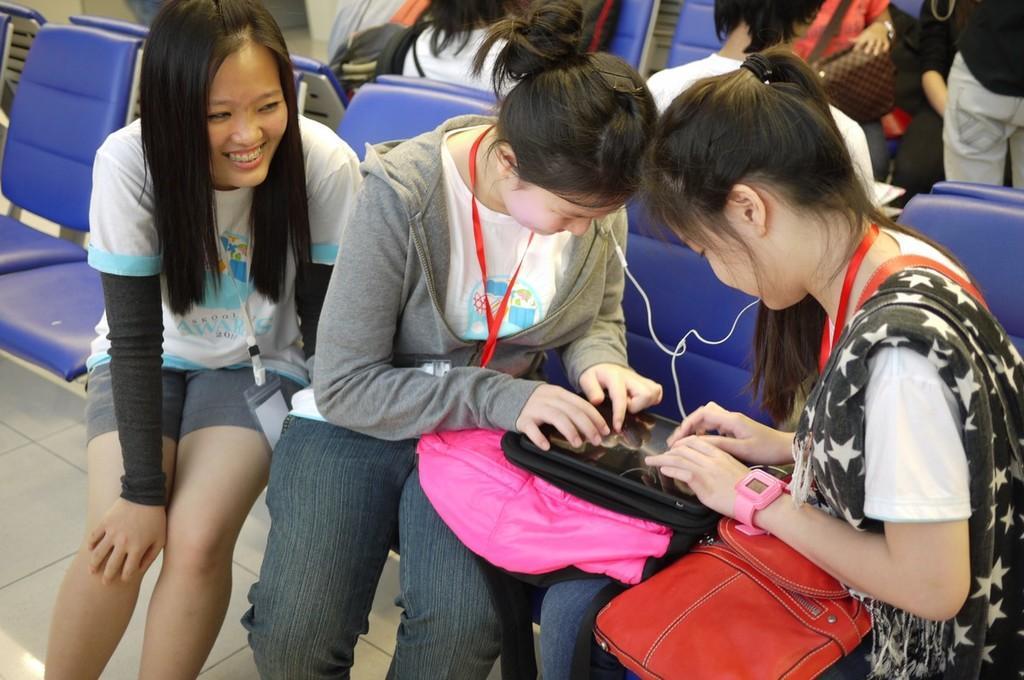Could you give a brief overview of what you see in this image? In this image we can see three girls are sitting on the chairs. At the top of the image, we can see men and women. Two girls are playing in an electronic device. We can see a red color bag on the lap of a girl and a pink color bag on the lap of the other girl. We can see tags around their necks. 